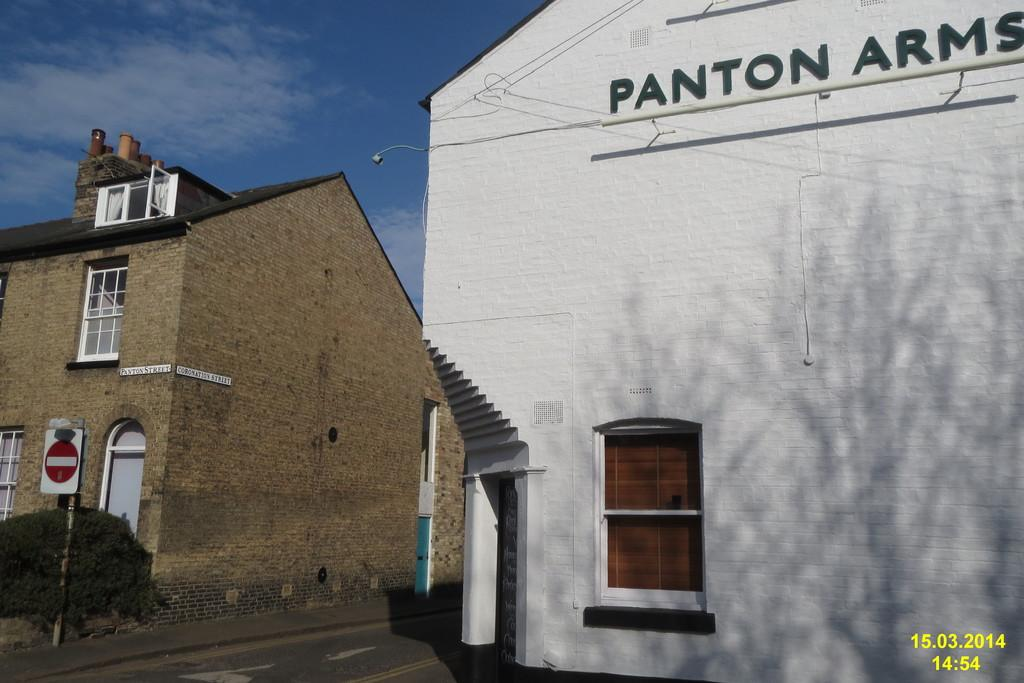<image>
Render a clear and concise summary of the photo. A white building that says Panton Arms stands next to a brick building in this photo dated 15.03.2014. 